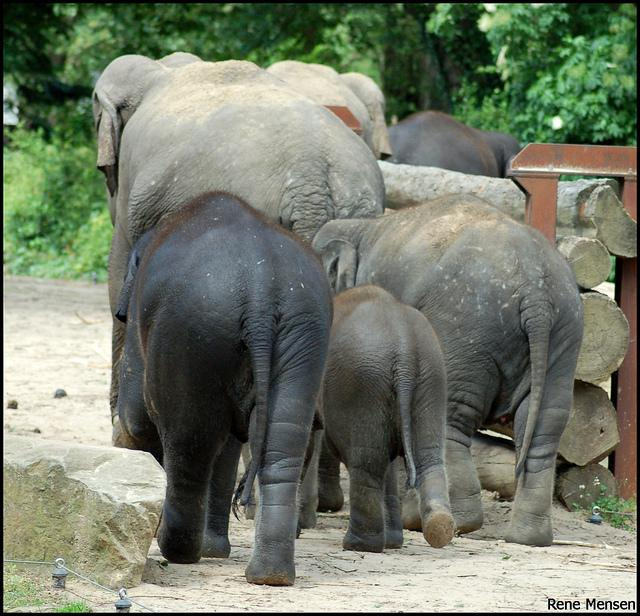What is this group of animals called? elephants 